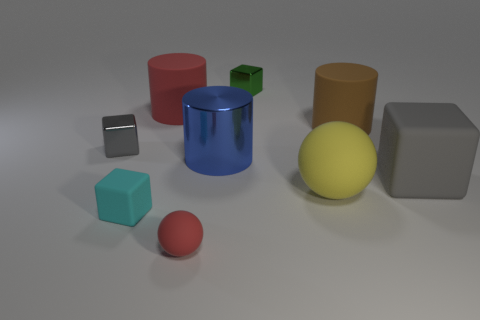What number of shiny things are blue cylinders or green blocks?
Provide a succinct answer. 2. What material is the blue thing?
Your answer should be compact. Metal. There is a gray object that is on the right side of the red object that is behind the big matte object to the right of the large brown cylinder; what is it made of?
Keep it short and to the point. Rubber. There is a red thing that is the same size as the gray metallic object; what shape is it?
Your response must be concise. Sphere. What number of objects are cyan cubes or big objects in front of the brown cylinder?
Keep it short and to the point. 4. Is the material of the ball that is to the right of the green cube the same as the gray block on the left side of the big gray object?
Your answer should be compact. No. The matte object that is the same color as the small ball is what shape?
Your response must be concise. Cylinder. How many gray objects are either small rubber cubes or rubber blocks?
Provide a short and direct response. 1. How big is the green shiny block?
Make the answer very short. Small. Is the number of big red matte cylinders that are left of the big gray matte block greater than the number of big gray metal cylinders?
Provide a short and direct response. Yes. 